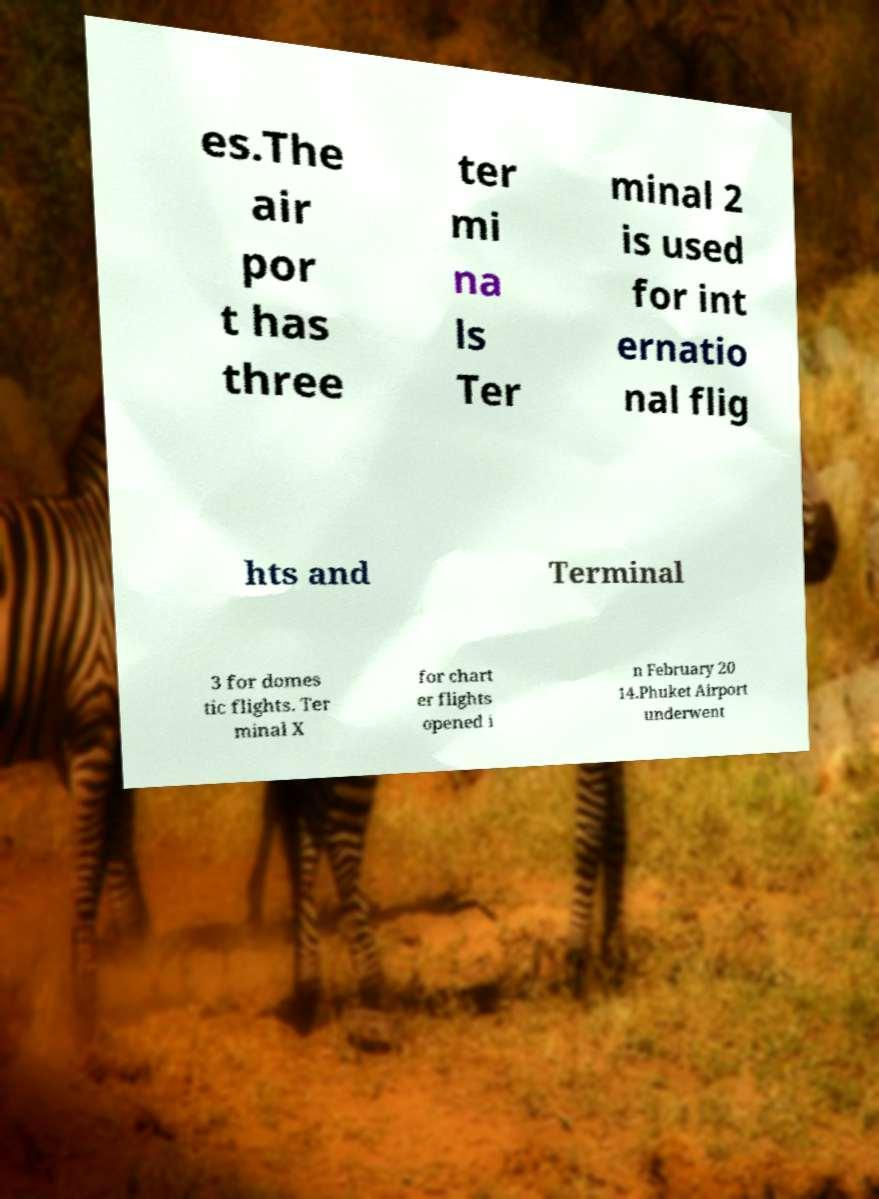I need the written content from this picture converted into text. Can you do that? es.The air por t has three ter mi na ls Ter minal 2 is used for int ernatio nal flig hts and Terminal 3 for domes tic flights. Ter minal X for chart er flights opened i n February 20 14.Phuket Airport underwent 